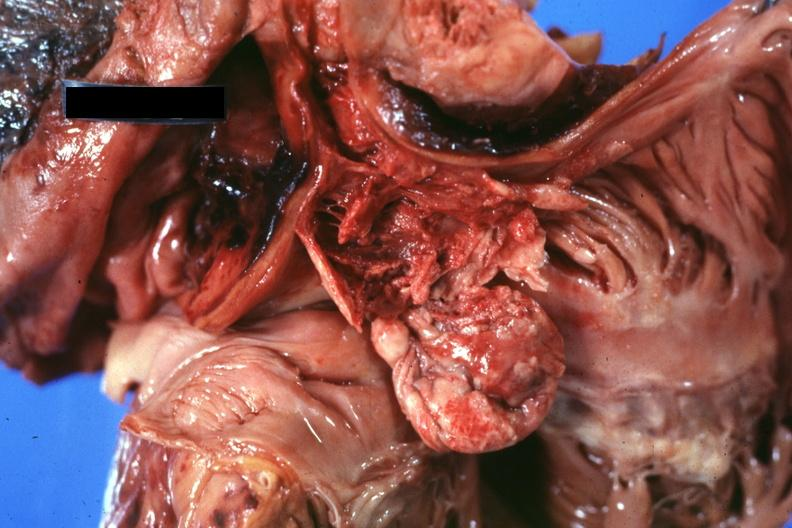s thymus present?
Answer the question using a single word or phrase. Yes 